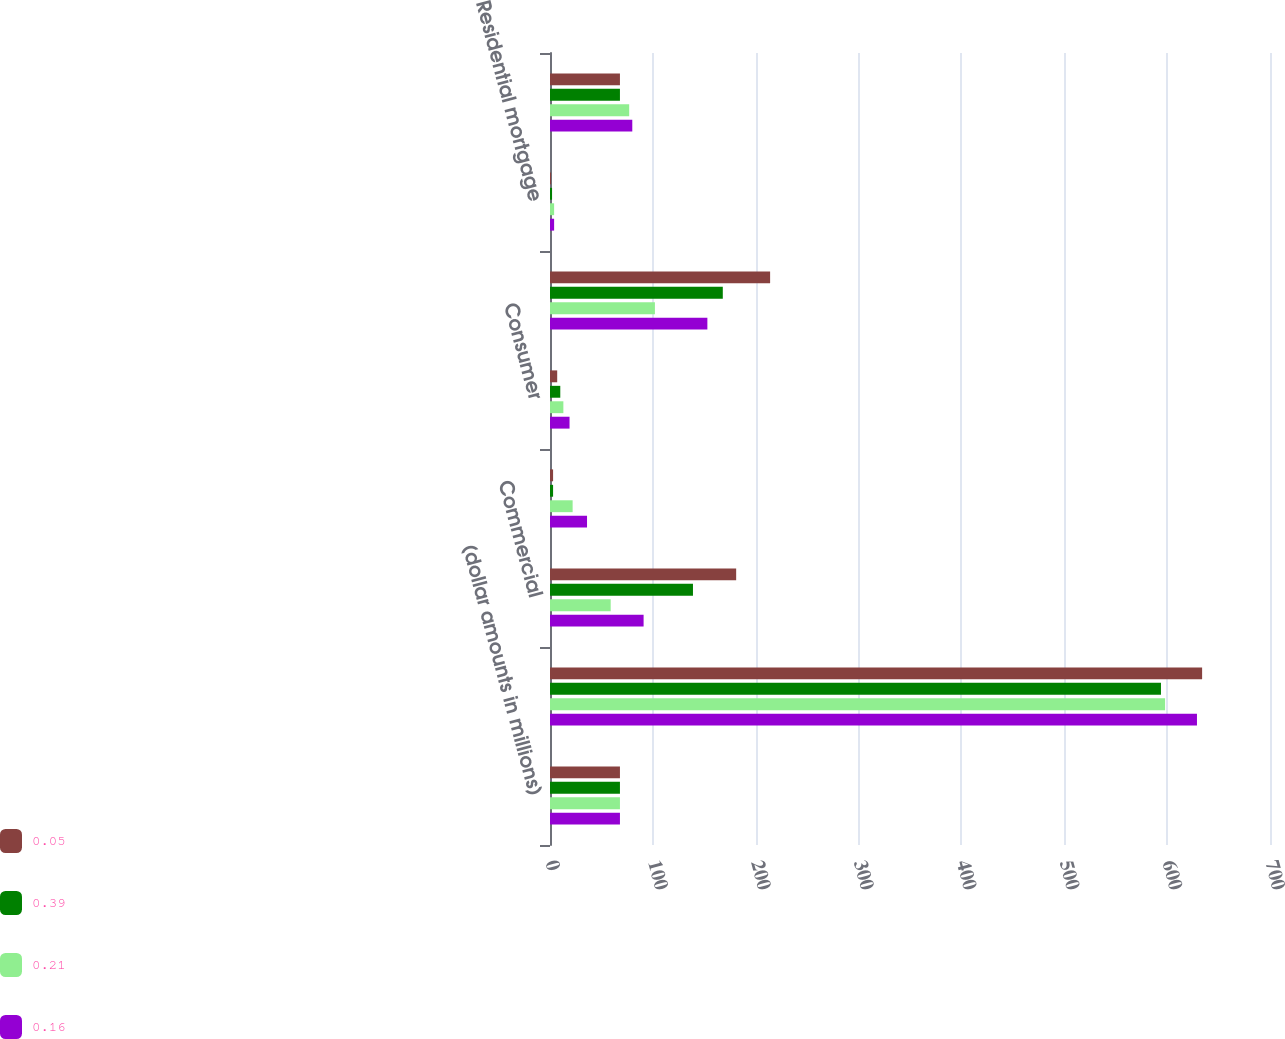<chart> <loc_0><loc_0><loc_500><loc_500><stacked_bar_chart><ecel><fcel>(dollar amounts in millions)<fcel>Balance at beginning of year<fcel>Commercial<fcel>Commercial mortgage<fcel>Consumer<fcel>Total loan charge-offs<fcel>Residential mortgage<fcel>Total recoveries<nl><fcel>0.05<fcel>68<fcel>634<fcel>181<fcel>3<fcel>7<fcel>214<fcel>1<fcel>68<nl><fcel>0.39<fcel>68<fcel>594<fcel>139<fcel>3<fcel>10<fcel>168<fcel>2<fcel>68<nl><fcel>0.21<fcel>68<fcel>598<fcel>59<fcel>22<fcel>13<fcel>102<fcel>4<fcel>77<nl><fcel>0.16<fcel>68<fcel>629<fcel>91<fcel>36<fcel>19<fcel>153<fcel>4<fcel>80<nl></chart> 